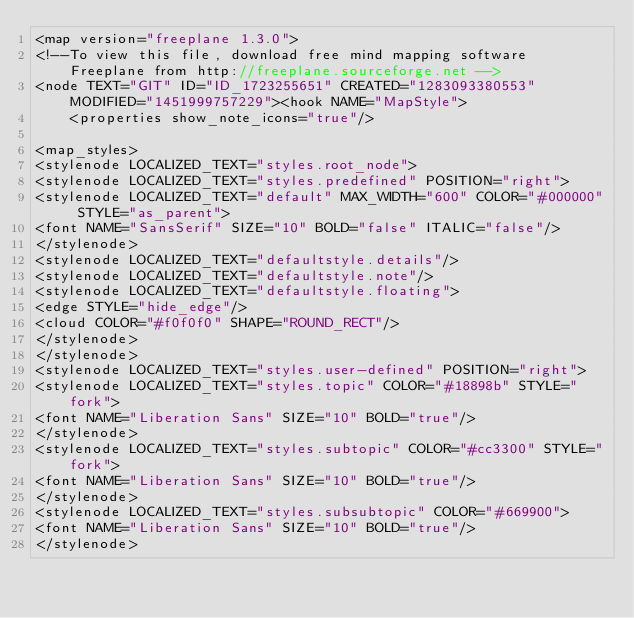<code> <loc_0><loc_0><loc_500><loc_500><_ObjectiveC_><map version="freeplane 1.3.0">
<!--To view this file, download free mind mapping software Freeplane from http://freeplane.sourceforge.net -->
<node TEXT="GIT" ID="ID_1723255651" CREATED="1283093380553" MODIFIED="1451999757229"><hook NAME="MapStyle">
    <properties show_note_icons="true"/>

<map_styles>
<stylenode LOCALIZED_TEXT="styles.root_node">
<stylenode LOCALIZED_TEXT="styles.predefined" POSITION="right">
<stylenode LOCALIZED_TEXT="default" MAX_WIDTH="600" COLOR="#000000" STYLE="as_parent">
<font NAME="SansSerif" SIZE="10" BOLD="false" ITALIC="false"/>
</stylenode>
<stylenode LOCALIZED_TEXT="defaultstyle.details"/>
<stylenode LOCALIZED_TEXT="defaultstyle.note"/>
<stylenode LOCALIZED_TEXT="defaultstyle.floating">
<edge STYLE="hide_edge"/>
<cloud COLOR="#f0f0f0" SHAPE="ROUND_RECT"/>
</stylenode>
</stylenode>
<stylenode LOCALIZED_TEXT="styles.user-defined" POSITION="right">
<stylenode LOCALIZED_TEXT="styles.topic" COLOR="#18898b" STYLE="fork">
<font NAME="Liberation Sans" SIZE="10" BOLD="true"/>
</stylenode>
<stylenode LOCALIZED_TEXT="styles.subtopic" COLOR="#cc3300" STYLE="fork">
<font NAME="Liberation Sans" SIZE="10" BOLD="true"/>
</stylenode>
<stylenode LOCALIZED_TEXT="styles.subsubtopic" COLOR="#669900">
<font NAME="Liberation Sans" SIZE="10" BOLD="true"/>
</stylenode></code> 